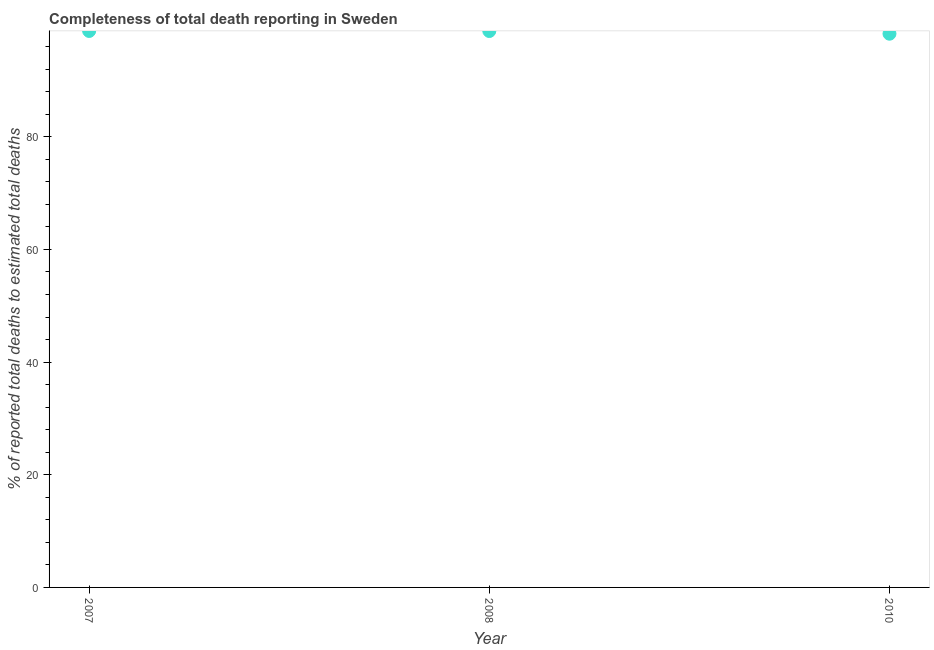What is the completeness of total death reports in 2007?
Provide a short and direct response. 98.78. Across all years, what is the maximum completeness of total death reports?
Provide a succinct answer. 98.78. Across all years, what is the minimum completeness of total death reports?
Offer a terse response. 98.3. In which year was the completeness of total death reports minimum?
Ensure brevity in your answer.  2010. What is the sum of the completeness of total death reports?
Make the answer very short. 295.85. What is the difference between the completeness of total death reports in 2007 and 2010?
Keep it short and to the point. 0.49. What is the average completeness of total death reports per year?
Your answer should be very brief. 98.62. What is the median completeness of total death reports?
Your response must be concise. 98.77. In how many years, is the completeness of total death reports greater than 12 %?
Ensure brevity in your answer.  3. What is the ratio of the completeness of total death reports in 2007 to that in 2010?
Offer a terse response. 1. Is the completeness of total death reports in 2008 less than that in 2010?
Offer a very short reply. No. Is the difference between the completeness of total death reports in 2007 and 2008 greater than the difference between any two years?
Keep it short and to the point. No. What is the difference between the highest and the second highest completeness of total death reports?
Your answer should be very brief. 0.01. What is the difference between the highest and the lowest completeness of total death reports?
Your answer should be compact. 0.49. Does the completeness of total death reports monotonically increase over the years?
Offer a terse response. No. How many dotlines are there?
Your answer should be very brief. 1. How many years are there in the graph?
Your answer should be compact. 3. Does the graph contain any zero values?
Provide a succinct answer. No. Does the graph contain grids?
Give a very brief answer. No. What is the title of the graph?
Give a very brief answer. Completeness of total death reporting in Sweden. What is the label or title of the Y-axis?
Make the answer very short. % of reported total deaths to estimated total deaths. What is the % of reported total deaths to estimated total deaths in 2007?
Your answer should be compact. 98.78. What is the % of reported total deaths to estimated total deaths in 2008?
Keep it short and to the point. 98.77. What is the % of reported total deaths to estimated total deaths in 2010?
Ensure brevity in your answer.  98.3. What is the difference between the % of reported total deaths to estimated total deaths in 2007 and 2008?
Ensure brevity in your answer.  0.01. What is the difference between the % of reported total deaths to estimated total deaths in 2007 and 2010?
Make the answer very short. 0.49. What is the difference between the % of reported total deaths to estimated total deaths in 2008 and 2010?
Provide a succinct answer. 0.48. What is the ratio of the % of reported total deaths to estimated total deaths in 2007 to that in 2008?
Your response must be concise. 1. What is the ratio of the % of reported total deaths to estimated total deaths in 2007 to that in 2010?
Keep it short and to the point. 1. 